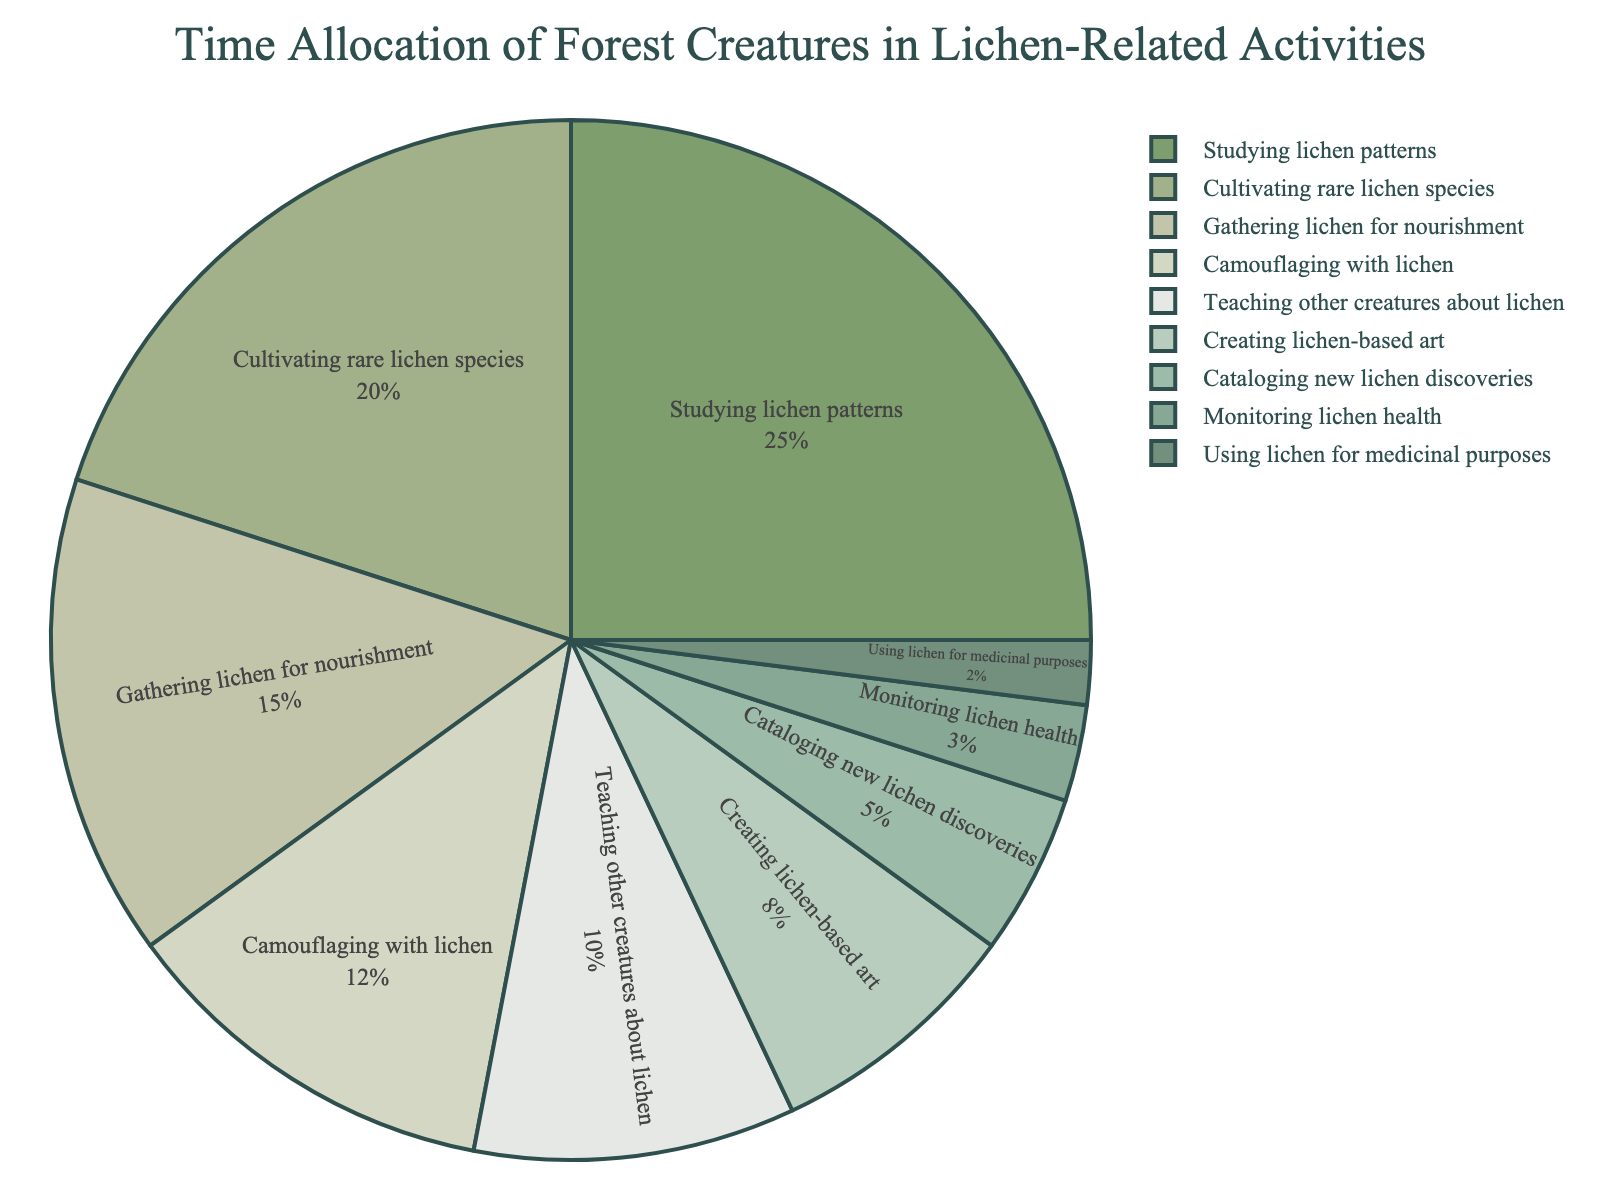What activity do forest creatures spend the most time on? The activity with the largest percentage segment in the pie chart is "Studying lichen patterns" at 25%.
Answer: Studying lichen patterns Which activity takes more time, cultivating rare lichen species or monitoring lichen health? Cultivating rare lichen species takes 20% of the time, while monitoring lichen health takes 3%.
Answer: Cultivating rare lichen species What percentage of time is spent on gathering lichen for nourishment compared to camouflaging with lichen? Gathering lichen for nourishment takes 15%, and camouflaging with lichen takes 12%.
Answer: Gathering lichen for nourishment What is the total percentage of time spent on teaching other creatures about lichen and creating lichen-based art? Teaching other creatures about lichen takes 10%, and creating lichen-based art takes 8%. Adding them together: 10% + 8% = 18%.
Answer: 18% How does the time spent on cataloging new lichen discoveries compare to using lichen for medicinal purposes? Cataloging new lichen discoveries is 5%, while using lichen for medicinal purposes is 2%.
Answer: Cataloging new lichen discoveries Which activity has a larger percentage: monitoring lichen health or using lichen for medicinal purposes? Monitoring lichen health has a larger percentage at 3%, compared to using lichen for medicinal purposes at 2%.
Answer: Monitoring lichen health What is the combined percentage of time spent on studying lichen patterns and cultivating rare lichen species? Studying lichen patterns takes 25%, and cultivating rare lichen species takes 20%. Adding them together: 25% + 20% = 45%.
Answer: 45% By how much does the percentage of time spent gathering lichen for nourishment exceed the time spent monitoring lichen health? Gathering lichen for nourishment takes 15%, and monitoring lichen health takes 3%. The difference is 15% - 3% = 12%.
Answer: 12% If forest creatures spent half the time studying lichen patterns, what would the new percentage allocation for studying lichen patterns be? Half of 25% is 12.5%.
Answer: 12.5% 